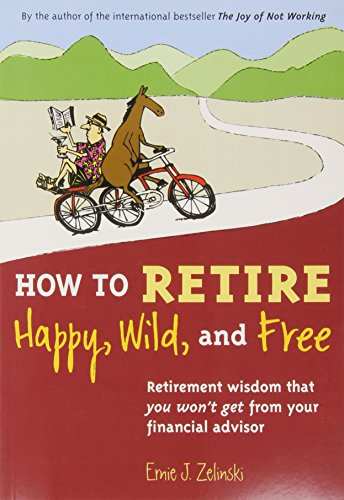Is this a christianity book? No, this book is not related to Christianity. It focuses on retirement and lifestyle advice. 